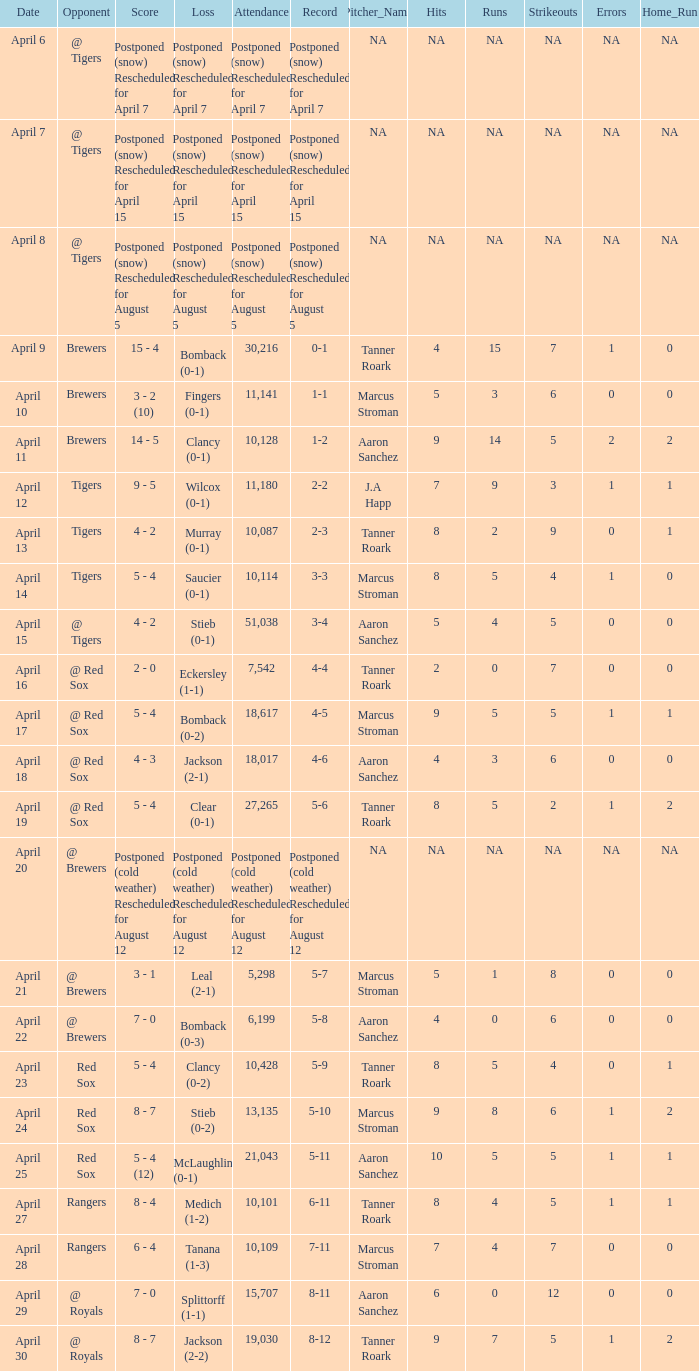What is the record for the game with an attendance of 11,141? 1-1. 